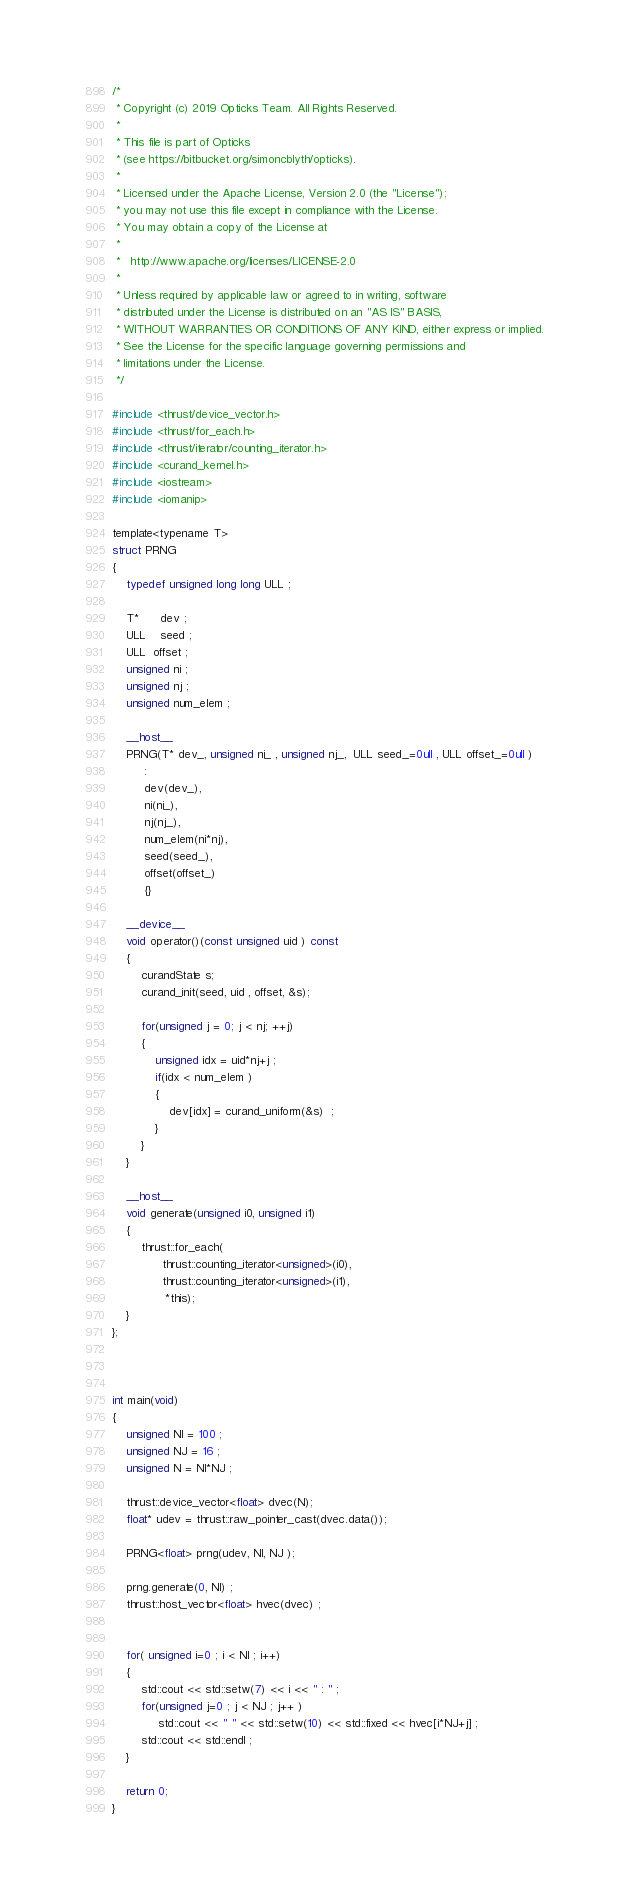Convert code to text. <code><loc_0><loc_0><loc_500><loc_500><_Cuda_>/*
 * Copyright (c) 2019 Opticks Team. All Rights Reserved.
 *
 * This file is part of Opticks
 * (see https://bitbucket.org/simoncblyth/opticks).
 *
 * Licensed under the Apache License, Version 2.0 (the "License"); 
 * you may not use this file except in compliance with the License.  
 * You may obtain a copy of the License at
 *
 *   http://www.apache.org/licenses/LICENSE-2.0
 *
 * Unless required by applicable law or agreed to in writing, software 
 * distributed under the License is distributed on an "AS IS" BASIS, 
 * WITHOUT WARRANTIES OR CONDITIONS OF ANY KIND, either express or implied.  
 * See the License for the specific language governing permissions and 
 * limitations under the License.
 */

#include <thrust/device_vector.h>
#include <thrust/for_each.h>
#include <thrust/iterator/counting_iterator.h>
#include <curand_kernel.h> 
#include <iostream>
#include <iomanip>

template<typename T>
struct PRNG
{
    typedef unsigned long long ULL ; 

    T*      dev ; 
    ULL    seed ; 
    ULL  offset ; 
    unsigned ni ; 
    unsigned nj ; 
    unsigned num_elem ; 

    __host__ 
    PRNG(T* dev_, unsigned ni_ , unsigned nj_,  ULL seed_=0ull , ULL offset_=0ull )
         : 
         dev(dev_),
         ni(ni_),
         nj(nj_),
         num_elem(ni*nj),
         seed(seed_), 
         offset(offset_)
         {}

    __device__
    void operator()(const unsigned uid ) const
    {
        curandState s;
        curand_init(seed, uid , offset, &s);

        for(unsigned j = 0; j < nj; ++j) 
        {   
            unsigned idx = uid*nj+j ;
            if(idx < num_elem )
            {   
                dev[idx] = curand_uniform(&s)  ;   
            }   
        }   
    }

    __host__
    void generate(unsigned i0, unsigned i1)
    {
        thrust::for_each(
              thrust::counting_iterator<unsigned>(i0),
              thrust::counting_iterator<unsigned>(i1),
               *this);
    }
};



int main(void)
{
    unsigned NI = 100 ;
    unsigned NJ = 16 ;
    unsigned N = NI*NJ ; 

    thrust::device_vector<float> dvec(N);
    float* udev = thrust::raw_pointer_cast(dvec.data()); 

    PRNG<float> prng(udev, NI, NJ ); 

    prng.generate(0, NI) ; 
    thrust::host_vector<float> hvec(dvec) ; 


    for( unsigned i=0 ; i < NI ; i++)
    {
        std::cout << std::setw(7) << i << " : " ; 
        for(unsigned j=0 ; j < NJ ; j++ )
             std::cout << " " << std::setw(10) << std::fixed << hvec[i*NJ+j] ; 
        std::cout << std::endl ; 
    }

    return 0;
}
</code> 